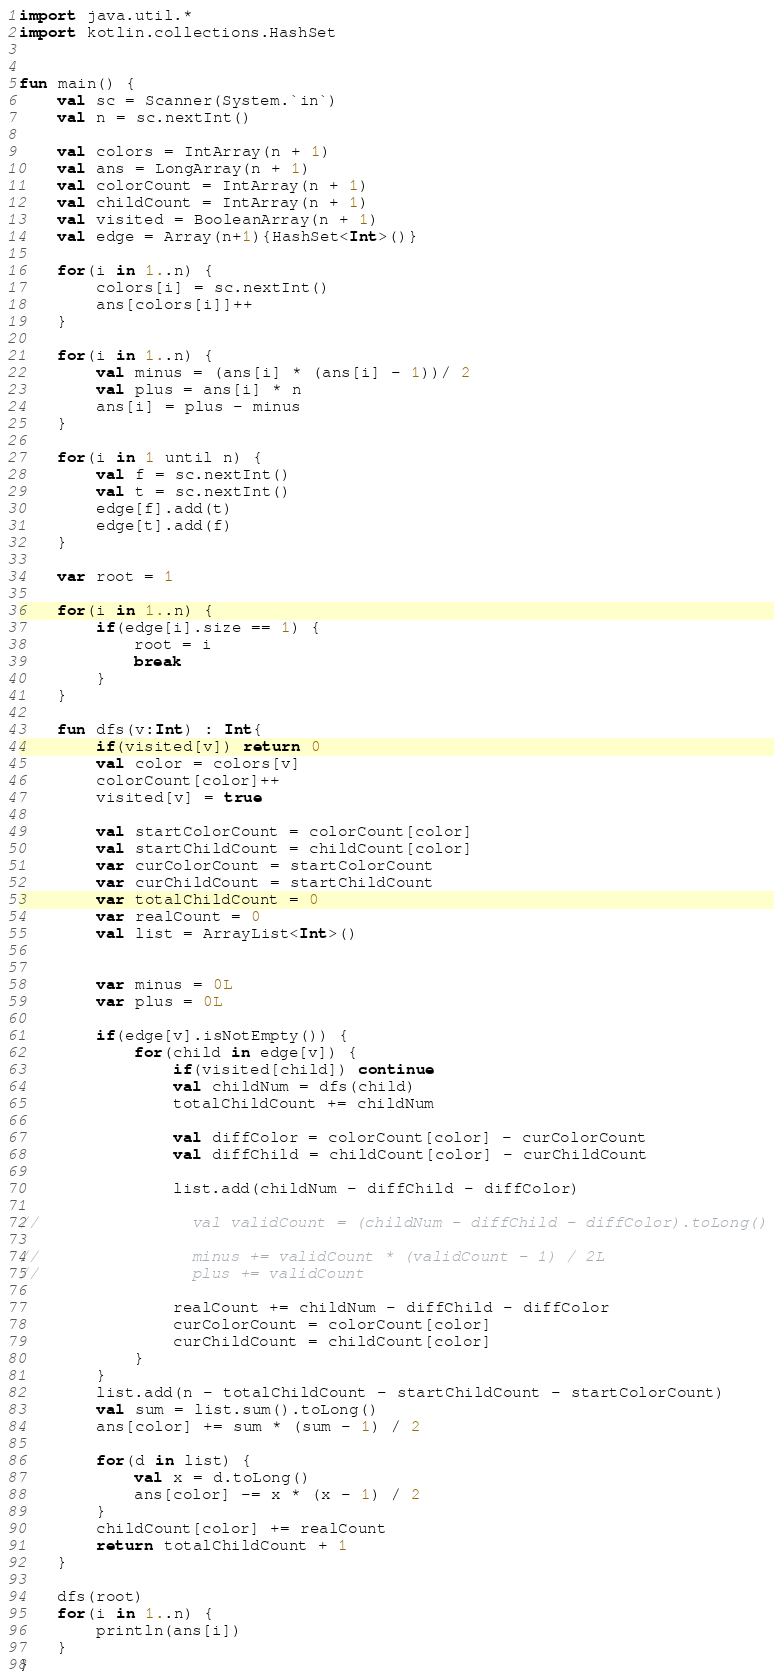<code> <loc_0><loc_0><loc_500><loc_500><_Kotlin_>import java.util.*
import kotlin.collections.HashSet


fun main() {
    val sc = Scanner(System.`in`)
    val n = sc.nextInt()

    val colors = IntArray(n + 1)
    val ans = LongArray(n + 1)
    val colorCount = IntArray(n + 1)
    val childCount = IntArray(n + 1)
    val visited = BooleanArray(n + 1)
    val edge = Array(n+1){HashSet<Int>()}

    for(i in 1..n) {
        colors[i] = sc.nextInt()
        ans[colors[i]]++
    }

    for(i in 1..n) {
        val minus = (ans[i] * (ans[i] - 1))/ 2
        val plus = ans[i] * n
        ans[i] = plus - minus
    }

    for(i in 1 until n) {
        val f = sc.nextInt()
        val t = sc.nextInt()
        edge[f].add(t)
        edge[t].add(f)
    }

    var root = 1

    for(i in 1..n) {
        if(edge[i].size == 1) {
            root = i
            break
        }
    }

    fun dfs(v:Int) : Int{
        if(visited[v]) return 0
        val color = colors[v]
        colorCount[color]++
        visited[v] = true

        val startColorCount = colorCount[color]
        val startChildCount = childCount[color]
        var curColorCount = startColorCount
        var curChildCount = startChildCount
        var totalChildCount = 0
        var realCount = 0
        val list = ArrayList<Int>()


        var minus = 0L
        var plus = 0L

        if(edge[v].isNotEmpty()) {
            for(child in edge[v]) {
                if(visited[child]) continue
                val childNum = dfs(child)
                totalChildCount += childNum

                val diffColor = colorCount[color] - curColorCount
                val diffChild = childCount[color] - curChildCount

                list.add(childNum - diffChild - diffColor)

//                val validCount = (childNum - diffChild - diffColor).toLong()

//                minus += validCount * (validCount - 1) / 2L
//                plus += validCount

                realCount += childNum - diffChild - diffColor
                curColorCount = colorCount[color]
                curChildCount = childCount[color]
            }
        }
        list.add(n - totalChildCount - startChildCount - startColorCount)
        val sum = list.sum().toLong()
        ans[color] += sum * (sum - 1) / 2

        for(d in list) {
            val x = d.toLong()
            ans[color] -= x * (x - 1) / 2
        }
        childCount[color] += realCount
        return totalChildCount + 1
    }

    dfs(root)
    for(i in 1..n) {
        println(ans[i])
    }
}</code> 